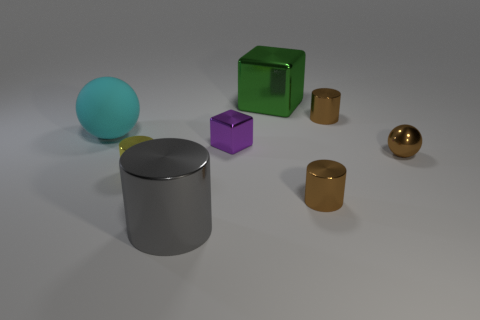Are there more tiny shiny objects right of the yellow shiny thing than red matte cylinders?
Your answer should be very brief. Yes. How many big green metallic cubes are on the left side of the large thing that is to the right of the small purple metal object?
Give a very brief answer. 0. The purple object behind the small brown shiny cylinder that is in front of the tiny shiny cylinder that is to the left of the big green shiny object is what shape?
Ensure brevity in your answer.  Cube. What size is the brown ball?
Offer a terse response. Small. Are there any large red cylinders that have the same material as the small purple cube?
Give a very brief answer. No. What size is the other thing that is the same shape as the green thing?
Provide a succinct answer. Small. Are there the same number of tiny balls that are behind the yellow cylinder and purple blocks?
Offer a very short reply. Yes. Does the big thing that is left of the large gray shiny cylinder have the same shape as the small yellow object?
Your response must be concise. No. There is a yellow object; what shape is it?
Provide a succinct answer. Cylinder. What material is the sphere that is left of the gray object that is in front of the brown metal object in front of the tiny yellow shiny object made of?
Make the answer very short. Rubber. 